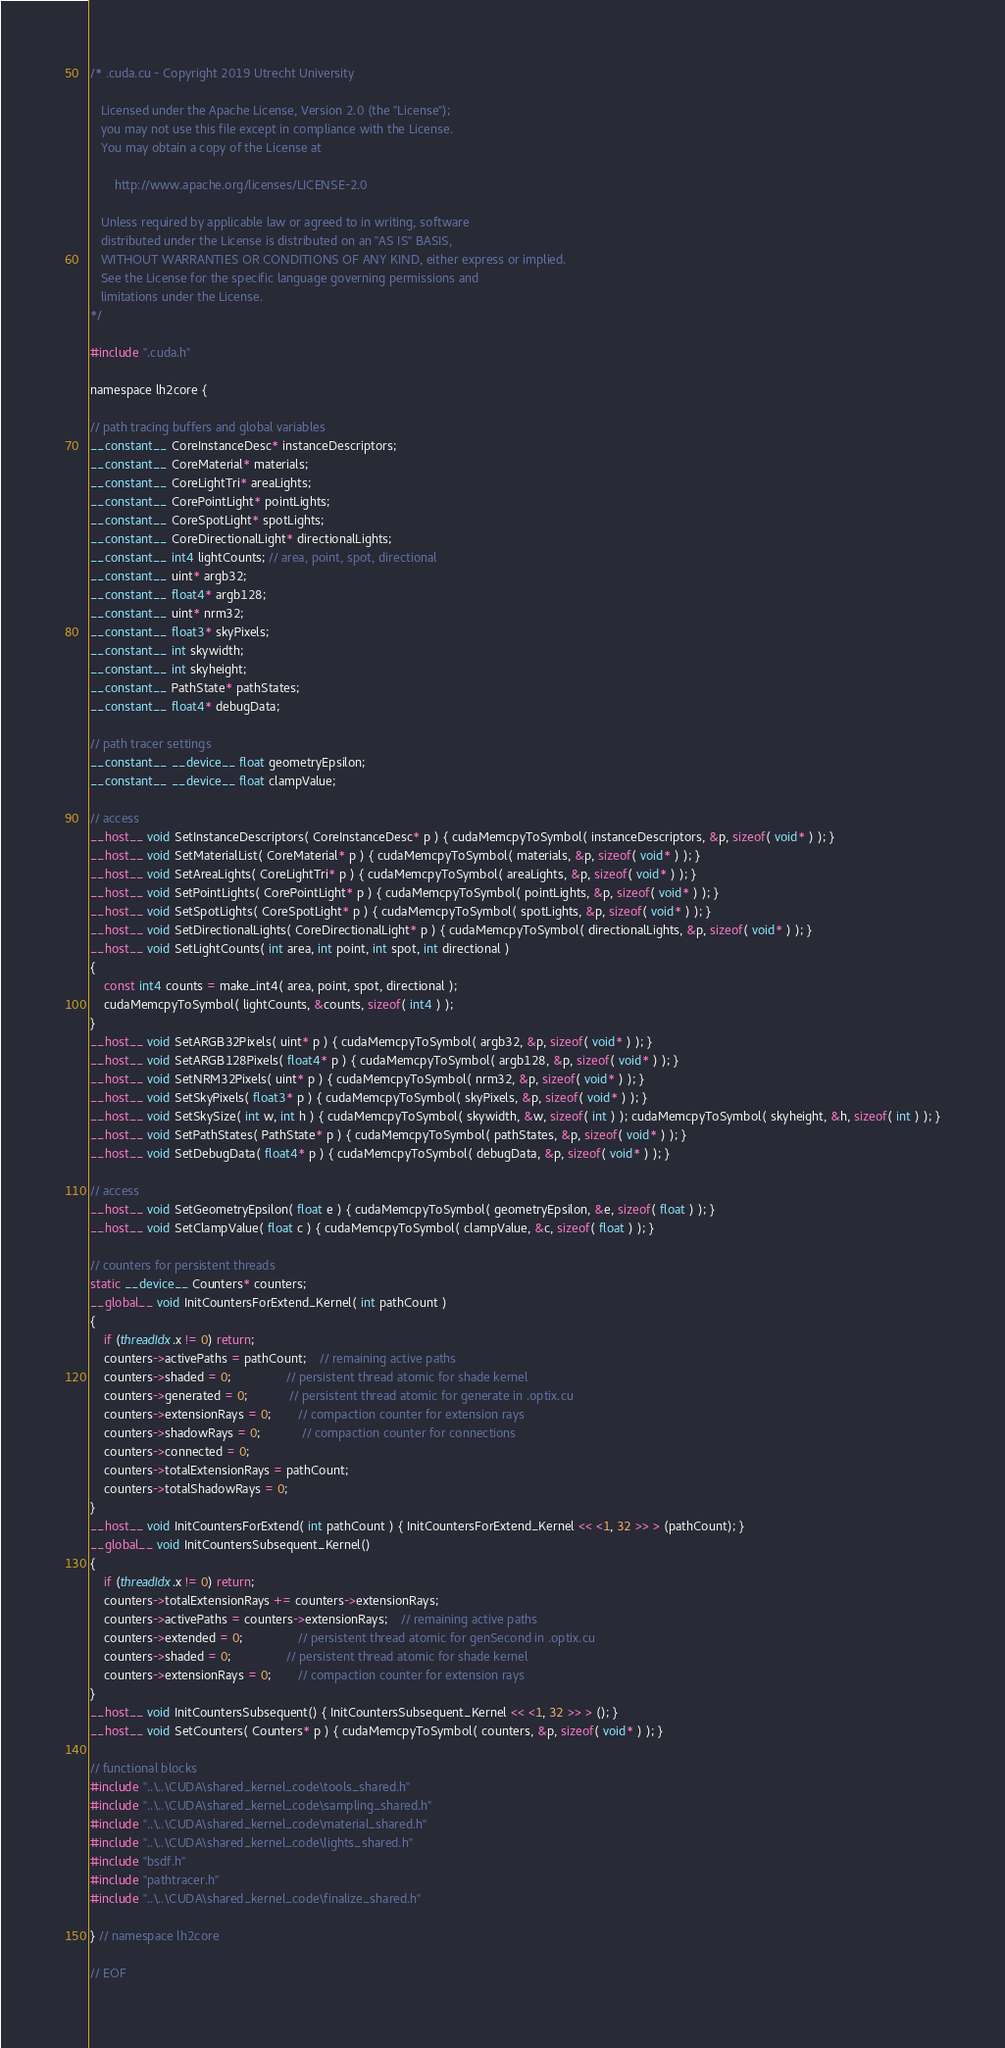Convert code to text. <code><loc_0><loc_0><loc_500><loc_500><_Cuda_>/* .cuda.cu - Copyright 2019 Utrecht University

   Licensed under the Apache License, Version 2.0 (the "License");
   you may not use this file except in compliance with the License.
   You may obtain a copy of the License at

	   http://www.apache.org/licenses/LICENSE-2.0

   Unless required by applicable law or agreed to in writing, software
   distributed under the License is distributed on an "AS IS" BASIS,
   WITHOUT WARRANTIES OR CONDITIONS OF ANY KIND, either express or implied.
   See the License for the specific language governing permissions and
   limitations under the License.
*/

#include ".cuda.h"

namespace lh2core {

// path tracing buffers and global variables
__constant__ CoreInstanceDesc* instanceDescriptors;
__constant__ CoreMaterial* materials;
__constant__ CoreLightTri* areaLights;
__constant__ CorePointLight* pointLights;
__constant__ CoreSpotLight* spotLights;
__constant__ CoreDirectionalLight* directionalLights;
__constant__ int4 lightCounts; // area, point, spot, directional
__constant__ uint* argb32;
__constant__ float4* argb128;
__constant__ uint* nrm32;
__constant__ float3* skyPixels;
__constant__ int skywidth;
__constant__ int skyheight;
__constant__ PathState* pathStates;
__constant__ float4* debugData;

// path tracer settings
__constant__ __device__ float geometryEpsilon;
__constant__ __device__ float clampValue;

// access
__host__ void SetInstanceDescriptors( CoreInstanceDesc* p ) { cudaMemcpyToSymbol( instanceDescriptors, &p, sizeof( void* ) ); }
__host__ void SetMaterialList( CoreMaterial* p ) { cudaMemcpyToSymbol( materials, &p, sizeof( void* ) ); }
__host__ void SetAreaLights( CoreLightTri* p ) { cudaMemcpyToSymbol( areaLights, &p, sizeof( void* ) ); }
__host__ void SetPointLights( CorePointLight* p ) { cudaMemcpyToSymbol( pointLights, &p, sizeof( void* ) ); }
__host__ void SetSpotLights( CoreSpotLight* p ) { cudaMemcpyToSymbol( spotLights, &p, sizeof( void* ) ); }
__host__ void SetDirectionalLights( CoreDirectionalLight* p ) { cudaMemcpyToSymbol( directionalLights, &p, sizeof( void* ) ); }
__host__ void SetLightCounts( int area, int point, int spot, int directional )
{
	const int4 counts = make_int4( area, point, spot, directional );
	cudaMemcpyToSymbol( lightCounts, &counts, sizeof( int4 ) );
}
__host__ void SetARGB32Pixels( uint* p ) { cudaMemcpyToSymbol( argb32, &p, sizeof( void* ) ); }
__host__ void SetARGB128Pixels( float4* p ) { cudaMemcpyToSymbol( argb128, &p, sizeof( void* ) ); }
__host__ void SetNRM32Pixels( uint* p ) { cudaMemcpyToSymbol( nrm32, &p, sizeof( void* ) ); }
__host__ void SetSkyPixels( float3* p ) { cudaMemcpyToSymbol( skyPixels, &p, sizeof( void* ) ); }
__host__ void SetSkySize( int w, int h ) { cudaMemcpyToSymbol( skywidth, &w, sizeof( int ) ); cudaMemcpyToSymbol( skyheight, &h, sizeof( int ) ); }
__host__ void SetPathStates( PathState* p ) { cudaMemcpyToSymbol( pathStates, &p, sizeof( void* ) ); }
__host__ void SetDebugData( float4* p ) { cudaMemcpyToSymbol( debugData, &p, sizeof( void* ) ); }

// access
__host__ void SetGeometryEpsilon( float e ) { cudaMemcpyToSymbol( geometryEpsilon, &e, sizeof( float ) ); }
__host__ void SetClampValue( float c ) { cudaMemcpyToSymbol( clampValue, &c, sizeof( float ) ); }

// counters for persistent threads
static __device__ Counters* counters;
__global__ void InitCountersForExtend_Kernel( int pathCount )
{
	if (threadIdx.x != 0) return;
	counters->activePaths = pathCount;	// remaining active paths
	counters->shaded = 0;				// persistent thread atomic for shade kernel
	counters->generated = 0;			// persistent thread atomic for generate in .optix.cu
	counters->extensionRays = 0;		// compaction counter for extension rays
	counters->shadowRays = 0;			// compaction counter for connections
	counters->connected = 0;
	counters->totalExtensionRays = pathCount;
	counters->totalShadowRays = 0;
}
__host__ void InitCountersForExtend( int pathCount ) { InitCountersForExtend_Kernel << <1, 32 >> > (pathCount); }
__global__ void InitCountersSubsequent_Kernel()
{
	if (threadIdx.x != 0) return;
	counters->totalExtensionRays += counters->extensionRays;
	counters->activePaths = counters->extensionRays;	// remaining active paths
	counters->extended = 0;				// persistent thread atomic for genSecond in .optix.cu
	counters->shaded = 0;				// persistent thread atomic for shade kernel
	counters->extensionRays = 0;		// compaction counter for extension rays
}
__host__ void InitCountersSubsequent() { InitCountersSubsequent_Kernel << <1, 32 >> > (); }
__host__ void SetCounters( Counters* p ) { cudaMemcpyToSymbol( counters, &p, sizeof( void* ) ); }

// functional blocks
#include "..\..\CUDA\shared_kernel_code\tools_shared.h"
#include "..\..\CUDA\shared_kernel_code\sampling_shared.h"
#include "..\..\CUDA\shared_kernel_code\material_shared.h"
#include "..\..\CUDA\shared_kernel_code\lights_shared.h"
#include "bsdf.h"
#include "pathtracer.h"
#include "..\..\CUDA\shared_kernel_code\finalize_shared.h"

} // namespace lh2core

// EOF</code> 